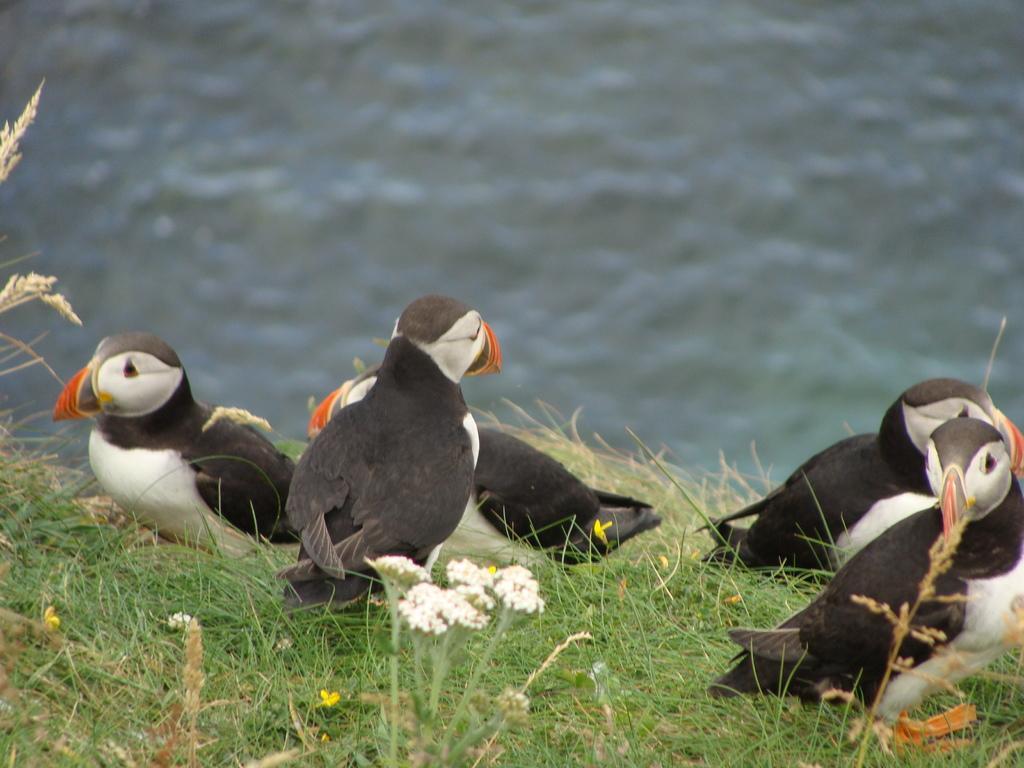How would you summarize this image in a sentence or two? In the center of the image we can see the Atlantic puffins. At the bottom of the image we can see the grass and flowers. At the top of the image we can see the water. 